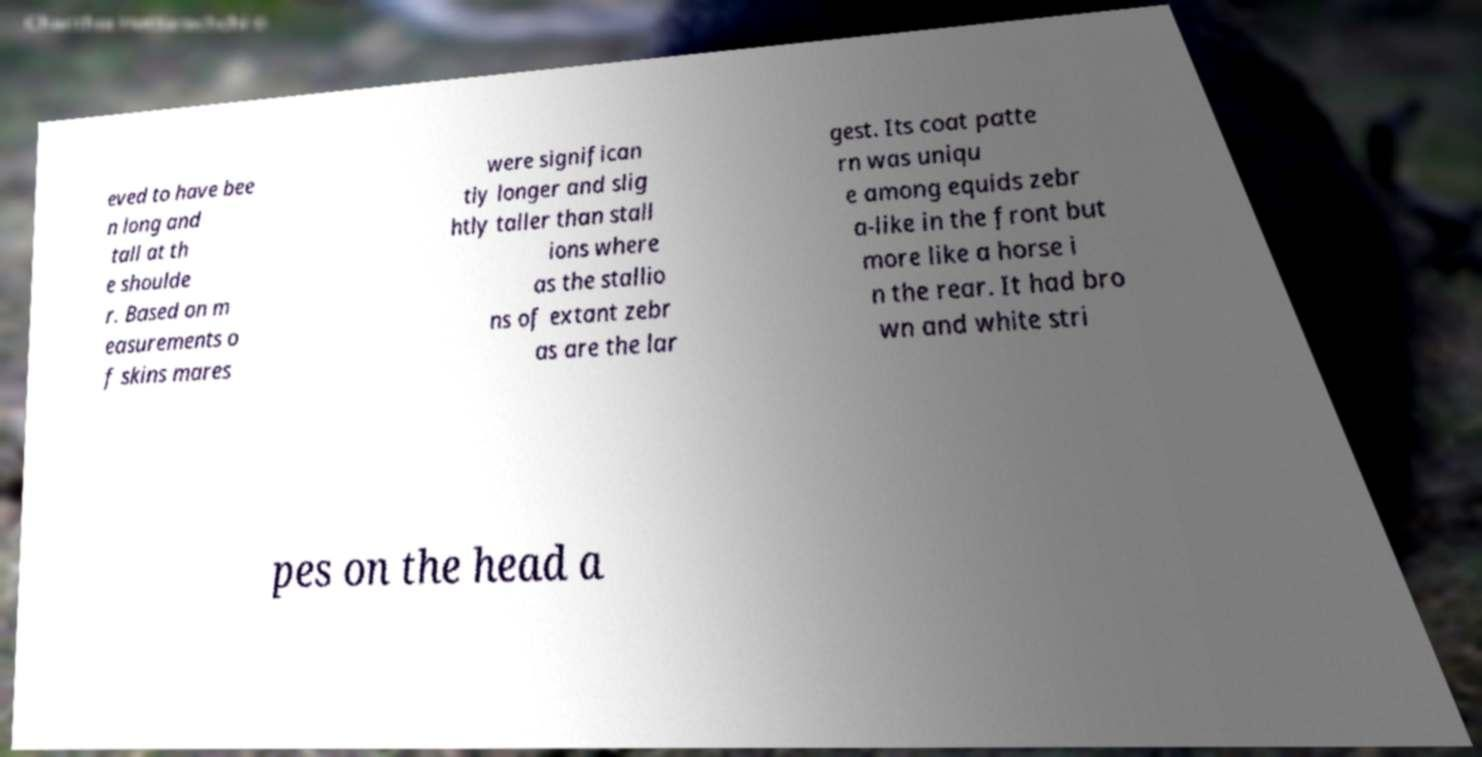Can you accurately transcribe the text from the provided image for me? eved to have bee n long and tall at th e shoulde r. Based on m easurements o f skins mares were significan tly longer and slig htly taller than stall ions where as the stallio ns of extant zebr as are the lar gest. Its coat patte rn was uniqu e among equids zebr a-like in the front but more like a horse i n the rear. It had bro wn and white stri pes on the head a 